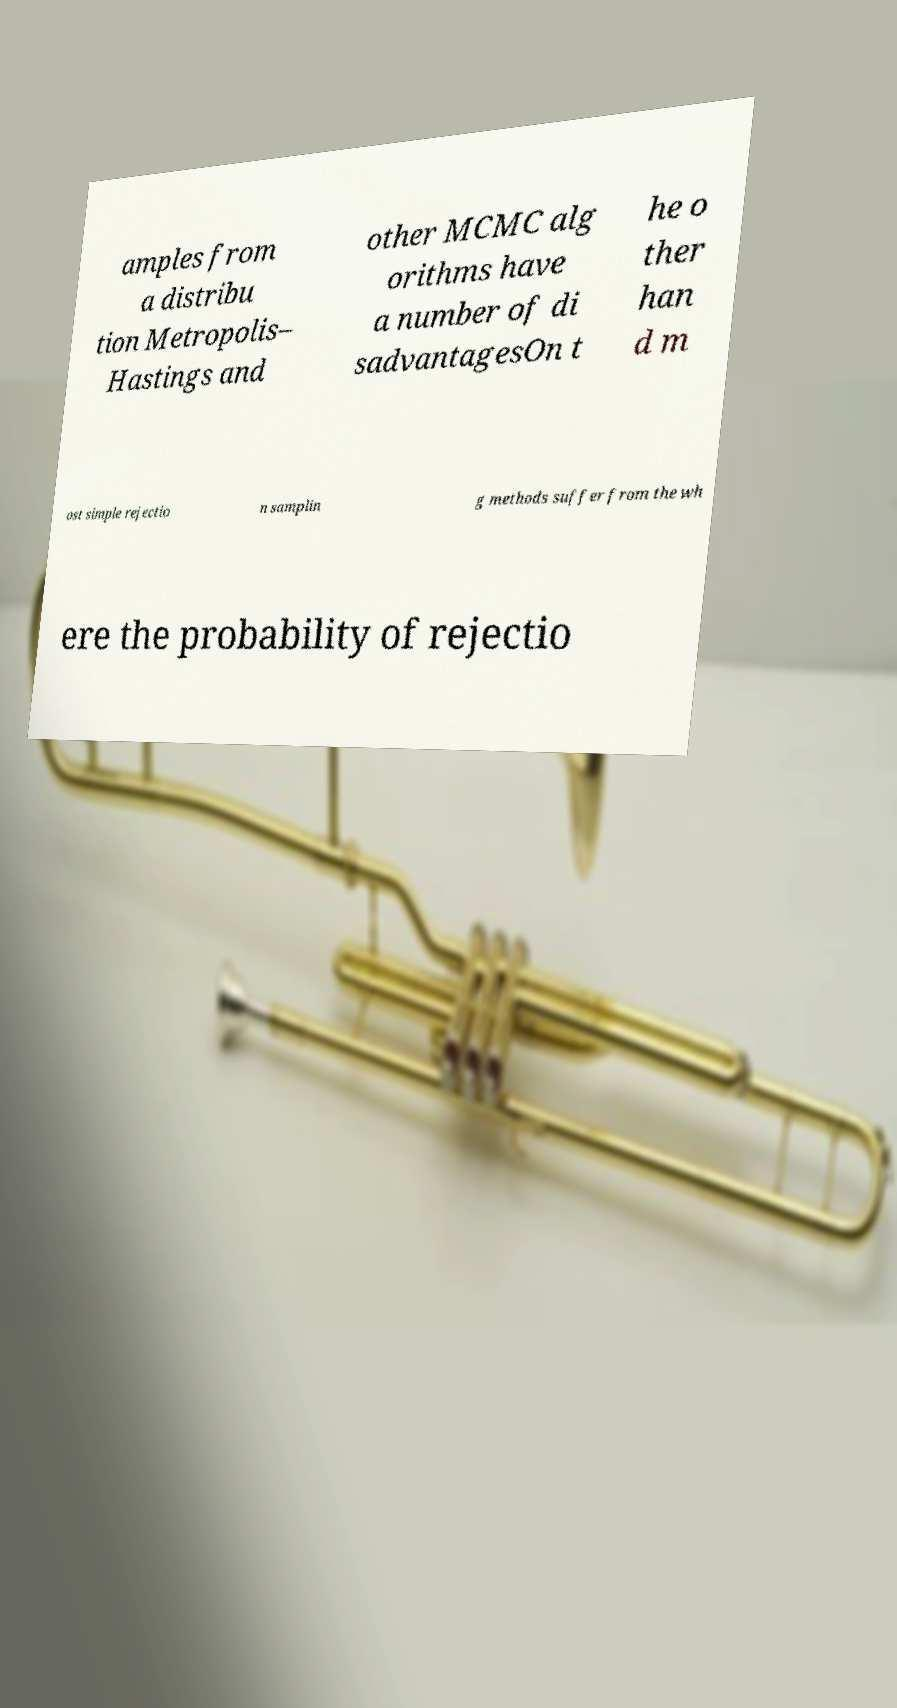Could you extract and type out the text from this image? amples from a distribu tion Metropolis– Hastings and other MCMC alg orithms have a number of di sadvantagesOn t he o ther han d m ost simple rejectio n samplin g methods suffer from the wh ere the probability of rejectio 